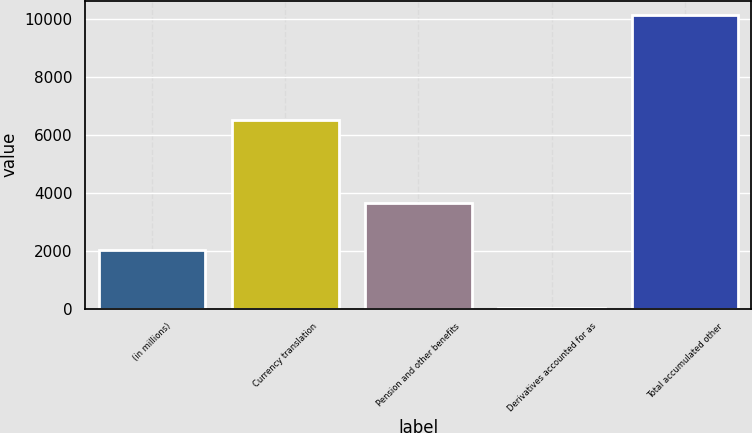<chart> <loc_0><loc_0><loc_500><loc_500><bar_chart><fcel>(in millions)<fcel>Currency translation<fcel>Pension and other benefits<fcel>Derivatives accounted for as<fcel>Total accumulated other<nl><fcel>2018<fcel>6500<fcel>3646<fcel>35<fcel>10111<nl></chart> 